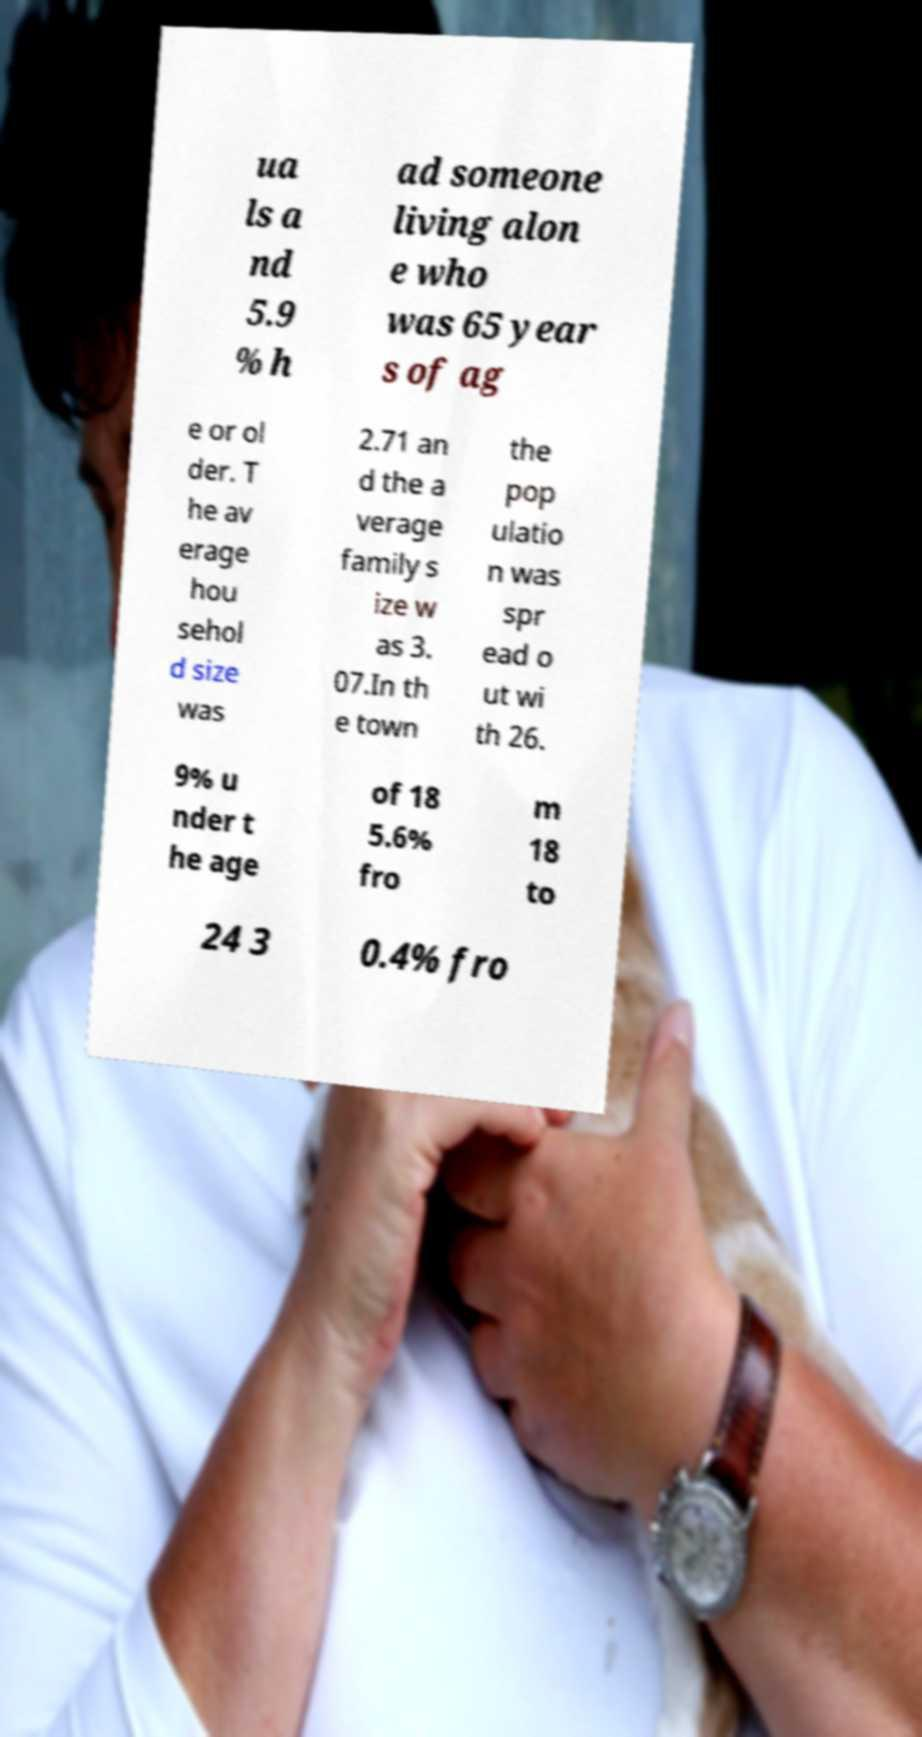I need the written content from this picture converted into text. Can you do that? ua ls a nd 5.9 % h ad someone living alon e who was 65 year s of ag e or ol der. T he av erage hou sehol d size was 2.71 an d the a verage family s ize w as 3. 07.In th e town the pop ulatio n was spr ead o ut wi th 26. 9% u nder t he age of 18 5.6% fro m 18 to 24 3 0.4% fro 